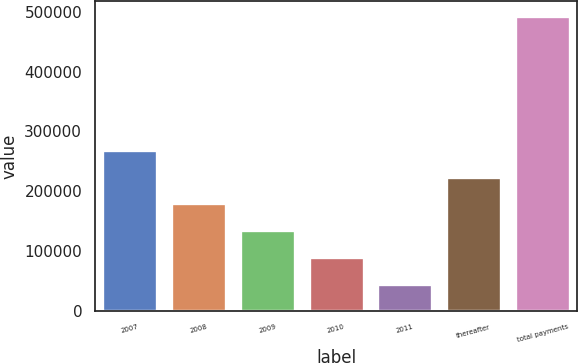Convert chart to OTSL. <chart><loc_0><loc_0><loc_500><loc_500><bar_chart><fcel>2007<fcel>2008<fcel>2009<fcel>2010<fcel>2011<fcel>thereafter<fcel>total payments<nl><fcel>269270<fcel>179600<fcel>134765<fcel>89930<fcel>45095<fcel>224435<fcel>493445<nl></chart> 